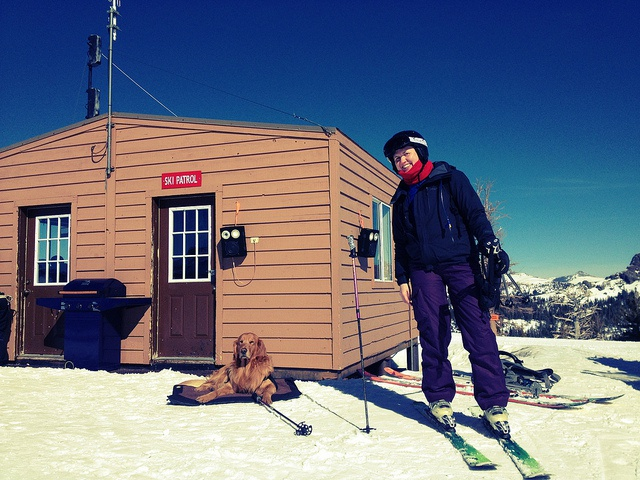Describe the objects in this image and their specific colors. I can see people in navy, black, gray, and beige tones, dog in navy, brown, tan, and maroon tones, skis in navy, khaki, teal, and lightyellow tones, and skis in navy, beige, darkgray, and gray tones in this image. 